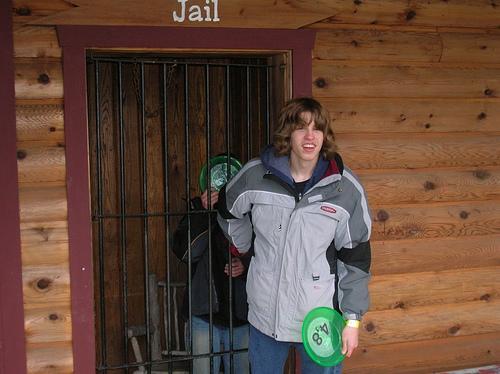What is the man holding in his hand?
Concise answer only. Frisbee. What numbers are in the plate?
Concise answer only. 48. What  does the sign say?
Concise answer only. Jail. 